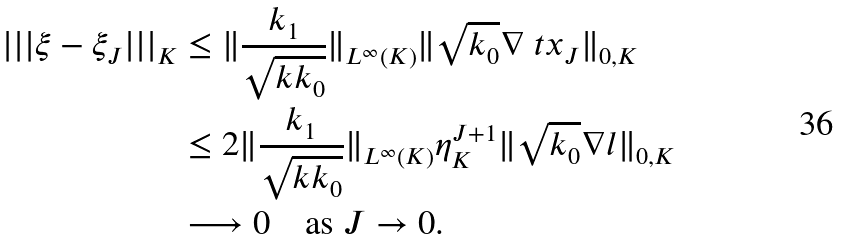Convert formula to latex. <formula><loc_0><loc_0><loc_500><loc_500>| | | \xi - \xi _ { J } | | | _ { K } & \leq \| \frac { k _ { 1 } } { \sqrt { k k _ { 0 } } } \| _ { L ^ { \infty } ( K ) } \| \sqrt { k _ { 0 } } \nabla \ t x _ { J } \| _ { 0 , K } \\ & \leq 2 \| \frac { k _ { 1 } } { \sqrt { k k _ { 0 } } } \| _ { L ^ { \infty } ( K ) } \eta _ { K } ^ { J + 1 } \| \sqrt { k _ { 0 } } \nabla l \| _ { 0 , K } \\ & \longrightarrow 0 \quad \text {as $J\rightarrow 0$} .</formula> 